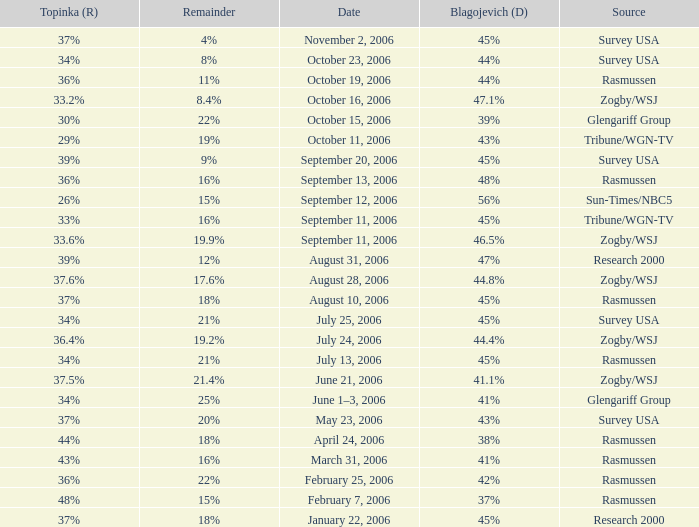Which Blagojevich (D) has a Source of zogby/wsj, and a Topinka (R) of 33.2%? 47.1%. 